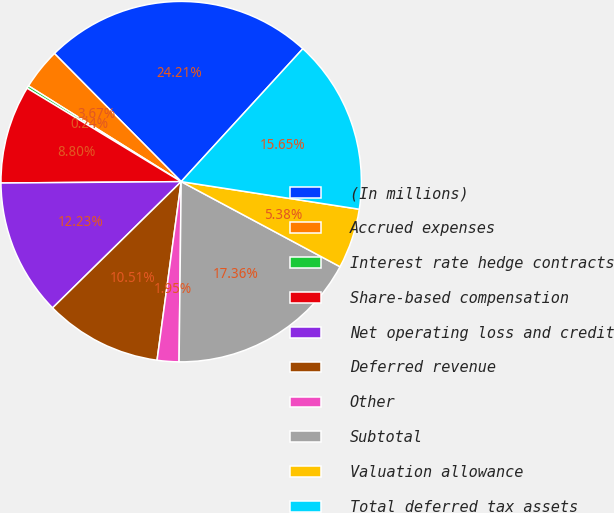Convert chart to OTSL. <chart><loc_0><loc_0><loc_500><loc_500><pie_chart><fcel>(In millions)<fcel>Accrued expenses<fcel>Interest rate hedge contracts<fcel>Share-based compensation<fcel>Net operating loss and credit<fcel>Deferred revenue<fcel>Other<fcel>Subtotal<fcel>Valuation allowance<fcel>Total deferred tax assets<nl><fcel>24.21%<fcel>3.67%<fcel>0.24%<fcel>8.8%<fcel>12.23%<fcel>10.51%<fcel>1.95%<fcel>17.36%<fcel>5.38%<fcel>15.65%<nl></chart> 